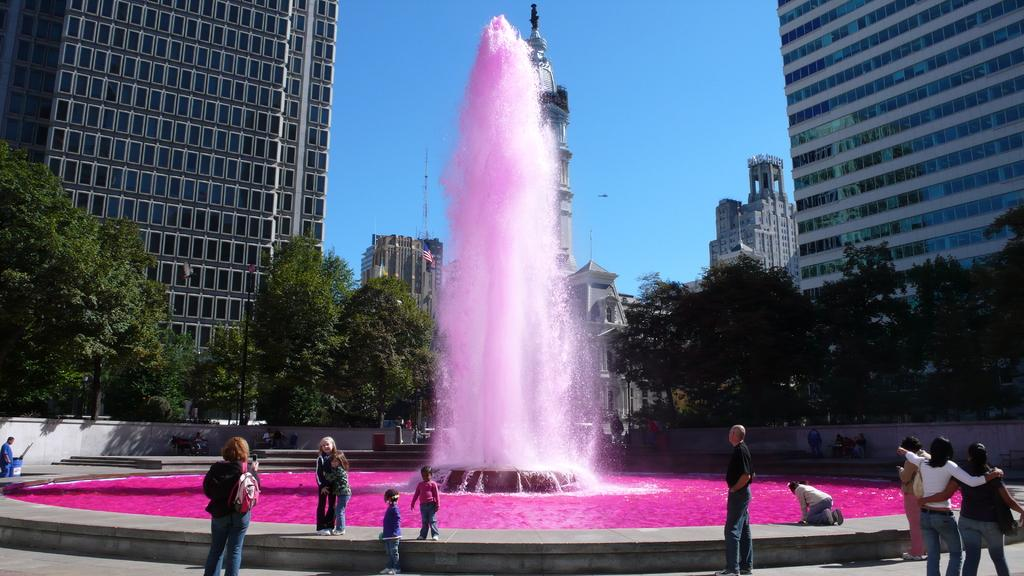What type of structures are visible in the image? There are tall buildings in the image. What is surrounding the buildings? The buildings are surrounded by trees. What is a notable feature in the image? There is a fountain in the image. What is unique about the water in the fountain? The water in the fountain is pink. What are the people near the fountain doing? The people standing near the fountain are looking at the fountain. What type of copper material can be seen on the people's tongues in the image? There is no copper material or mention of tongues in the image; it features tall buildings, trees, a fountain, and people looking at the fountain. What color is the hair of the people standing near the fountain? The image does not provide information about the color of the people's hair. 